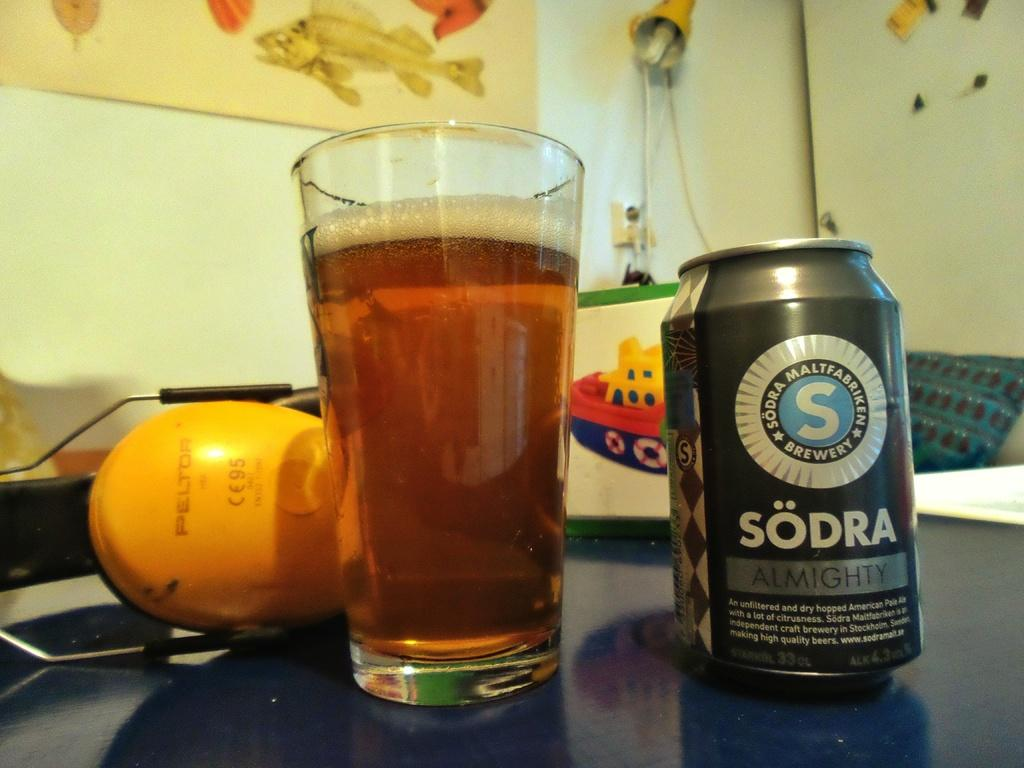<image>
Create a compact narrative representing the image presented. A ALUMINUM CAN CONTAINING SODRA ALMIGHTY SODA AND GLASS 